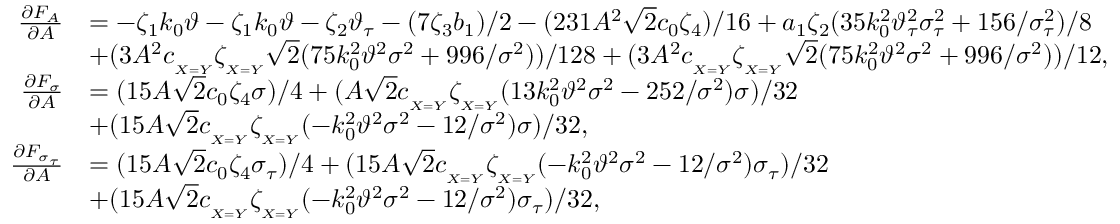Convert formula to latex. <formula><loc_0><loc_0><loc_500><loc_500>\begin{array} { r l } { \frac { \partial F _ { A } } { \partial A } } & { = - \zeta _ { 1 } k _ { 0 } \vartheta - \zeta _ { 1 } k _ { 0 } \vartheta - \zeta _ { 2 } \vartheta _ { \tau } - ( 7 \zeta _ { 3 } b _ { 1 } ) / 2 - ( 2 3 1 A ^ { 2 } \sqrt { 2 } c _ { 0 } \zeta _ { 4 } ) / 1 6 + a _ { 1 } \zeta _ { 2 } ( 3 5 k _ { 0 } ^ { 2 } \vartheta _ { \tau } ^ { 2 } \sigma _ { \tau } ^ { 2 } + 1 5 6 / \sigma _ { \tau } ^ { 2 } ) / 8 } \\ & { + ( 3 A ^ { 2 } c _ { _ { X = Y } } \zeta _ { _ { X = Y } } \sqrt { 2 } ( 7 5 k _ { 0 } ^ { 2 } \vartheta ^ { 2 } \sigma ^ { 2 } + 9 9 6 / \sigma ^ { 2 } ) ) / 1 2 8 + ( 3 A ^ { 2 } c _ { _ { X = Y } } \zeta _ { _ { X = Y } } \sqrt { 2 } ( 7 5 k _ { 0 } ^ { 2 } \vartheta ^ { 2 } \sigma ^ { 2 } + 9 9 6 / \sigma ^ { 2 } ) ) / 1 2 , } \\ { \frac { \partial F _ { \sigma } } { \partial A } } & { = ( 1 5 A \sqrt { 2 } c _ { 0 } \zeta _ { 4 } \sigma ) / 4 + ( A \sqrt { 2 } c _ { _ { X = Y } } \zeta _ { _ { X = Y } } ( 1 3 k _ { 0 } ^ { 2 } \vartheta ^ { 2 } \sigma ^ { 2 } - 2 5 2 / \sigma ^ { 2 } ) \sigma ) / 3 2 } \\ & { + ( 1 5 A \sqrt { 2 } c _ { _ { X = Y } } \zeta _ { _ { X = Y } } ( - k _ { 0 } ^ { 2 } \vartheta ^ { 2 } \sigma ^ { 2 } - 1 2 / \sigma ^ { 2 } ) \sigma ) / 3 2 , } \\ { \frac { \partial F _ { \sigma _ { \tau } } } { \partial A } } & { = ( 1 5 A \sqrt { 2 } c _ { 0 } \zeta _ { 4 } \sigma _ { \tau } ) / 4 + ( 1 5 A \sqrt { 2 } c _ { _ { X = Y } } \zeta _ { _ { X = Y } } ( - k _ { 0 } ^ { 2 } \vartheta ^ { 2 } \sigma ^ { 2 } - 1 2 / \sigma ^ { 2 } ) \sigma _ { \tau } ) / 3 2 } \\ & { + ( 1 5 A \sqrt { 2 } c _ { _ { X = Y } } \zeta _ { _ { X = Y } } ( - k _ { 0 } ^ { 2 } \vartheta ^ { 2 } \sigma ^ { 2 } - 1 2 / \sigma ^ { 2 } ) \sigma _ { \tau } ) / 3 2 , } \end{array}</formula> 